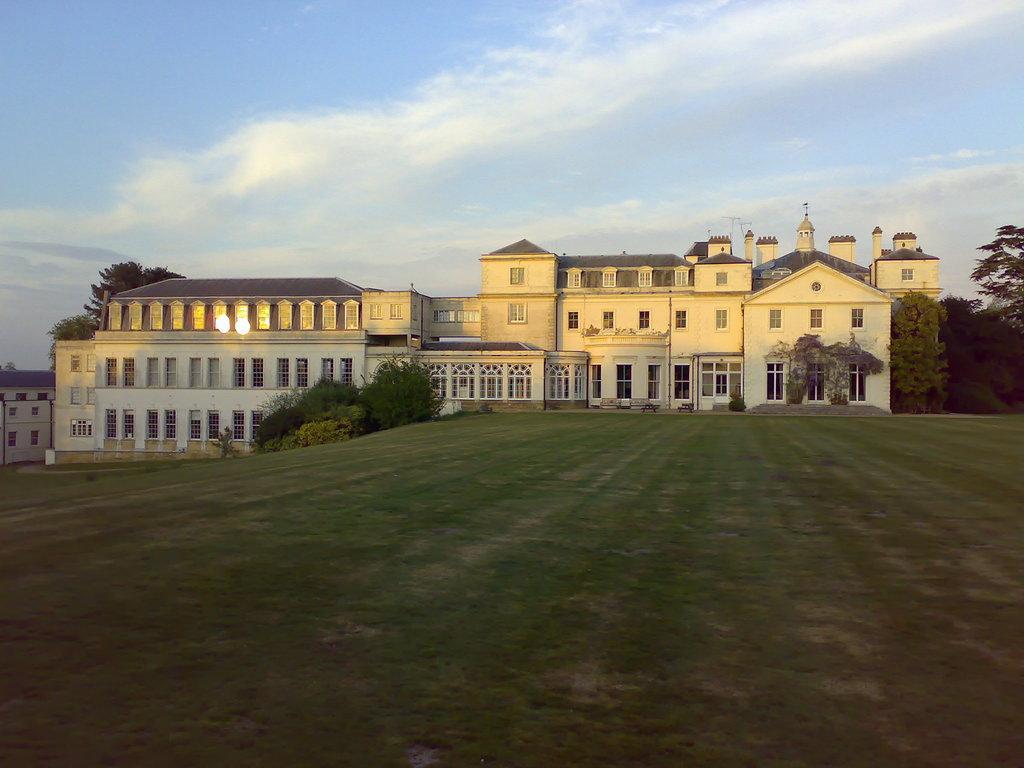Can you describe this image briefly? In this image, we can see buildings, trees, plants, grass, windows and walls. Background there is a sky. 